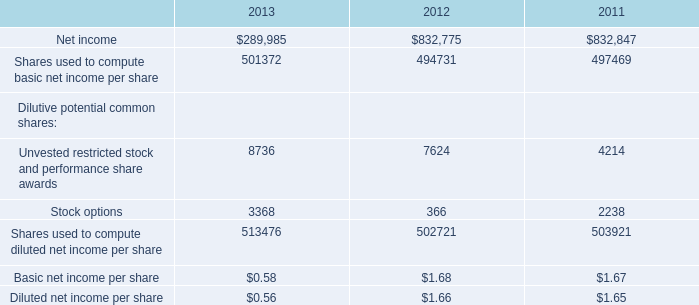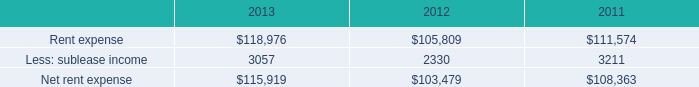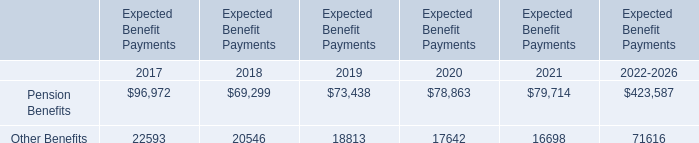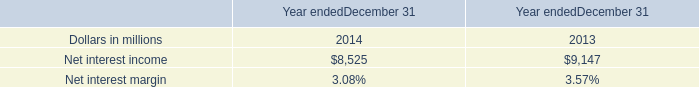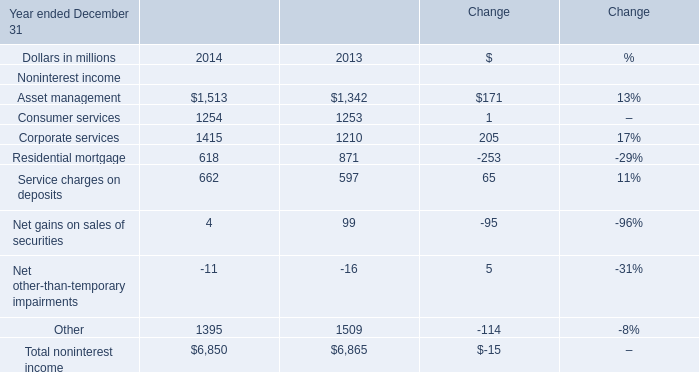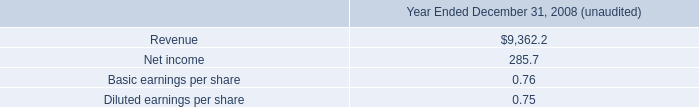The total amount of which section ranks first in 2014? 
Answer: Total noninterest income. 